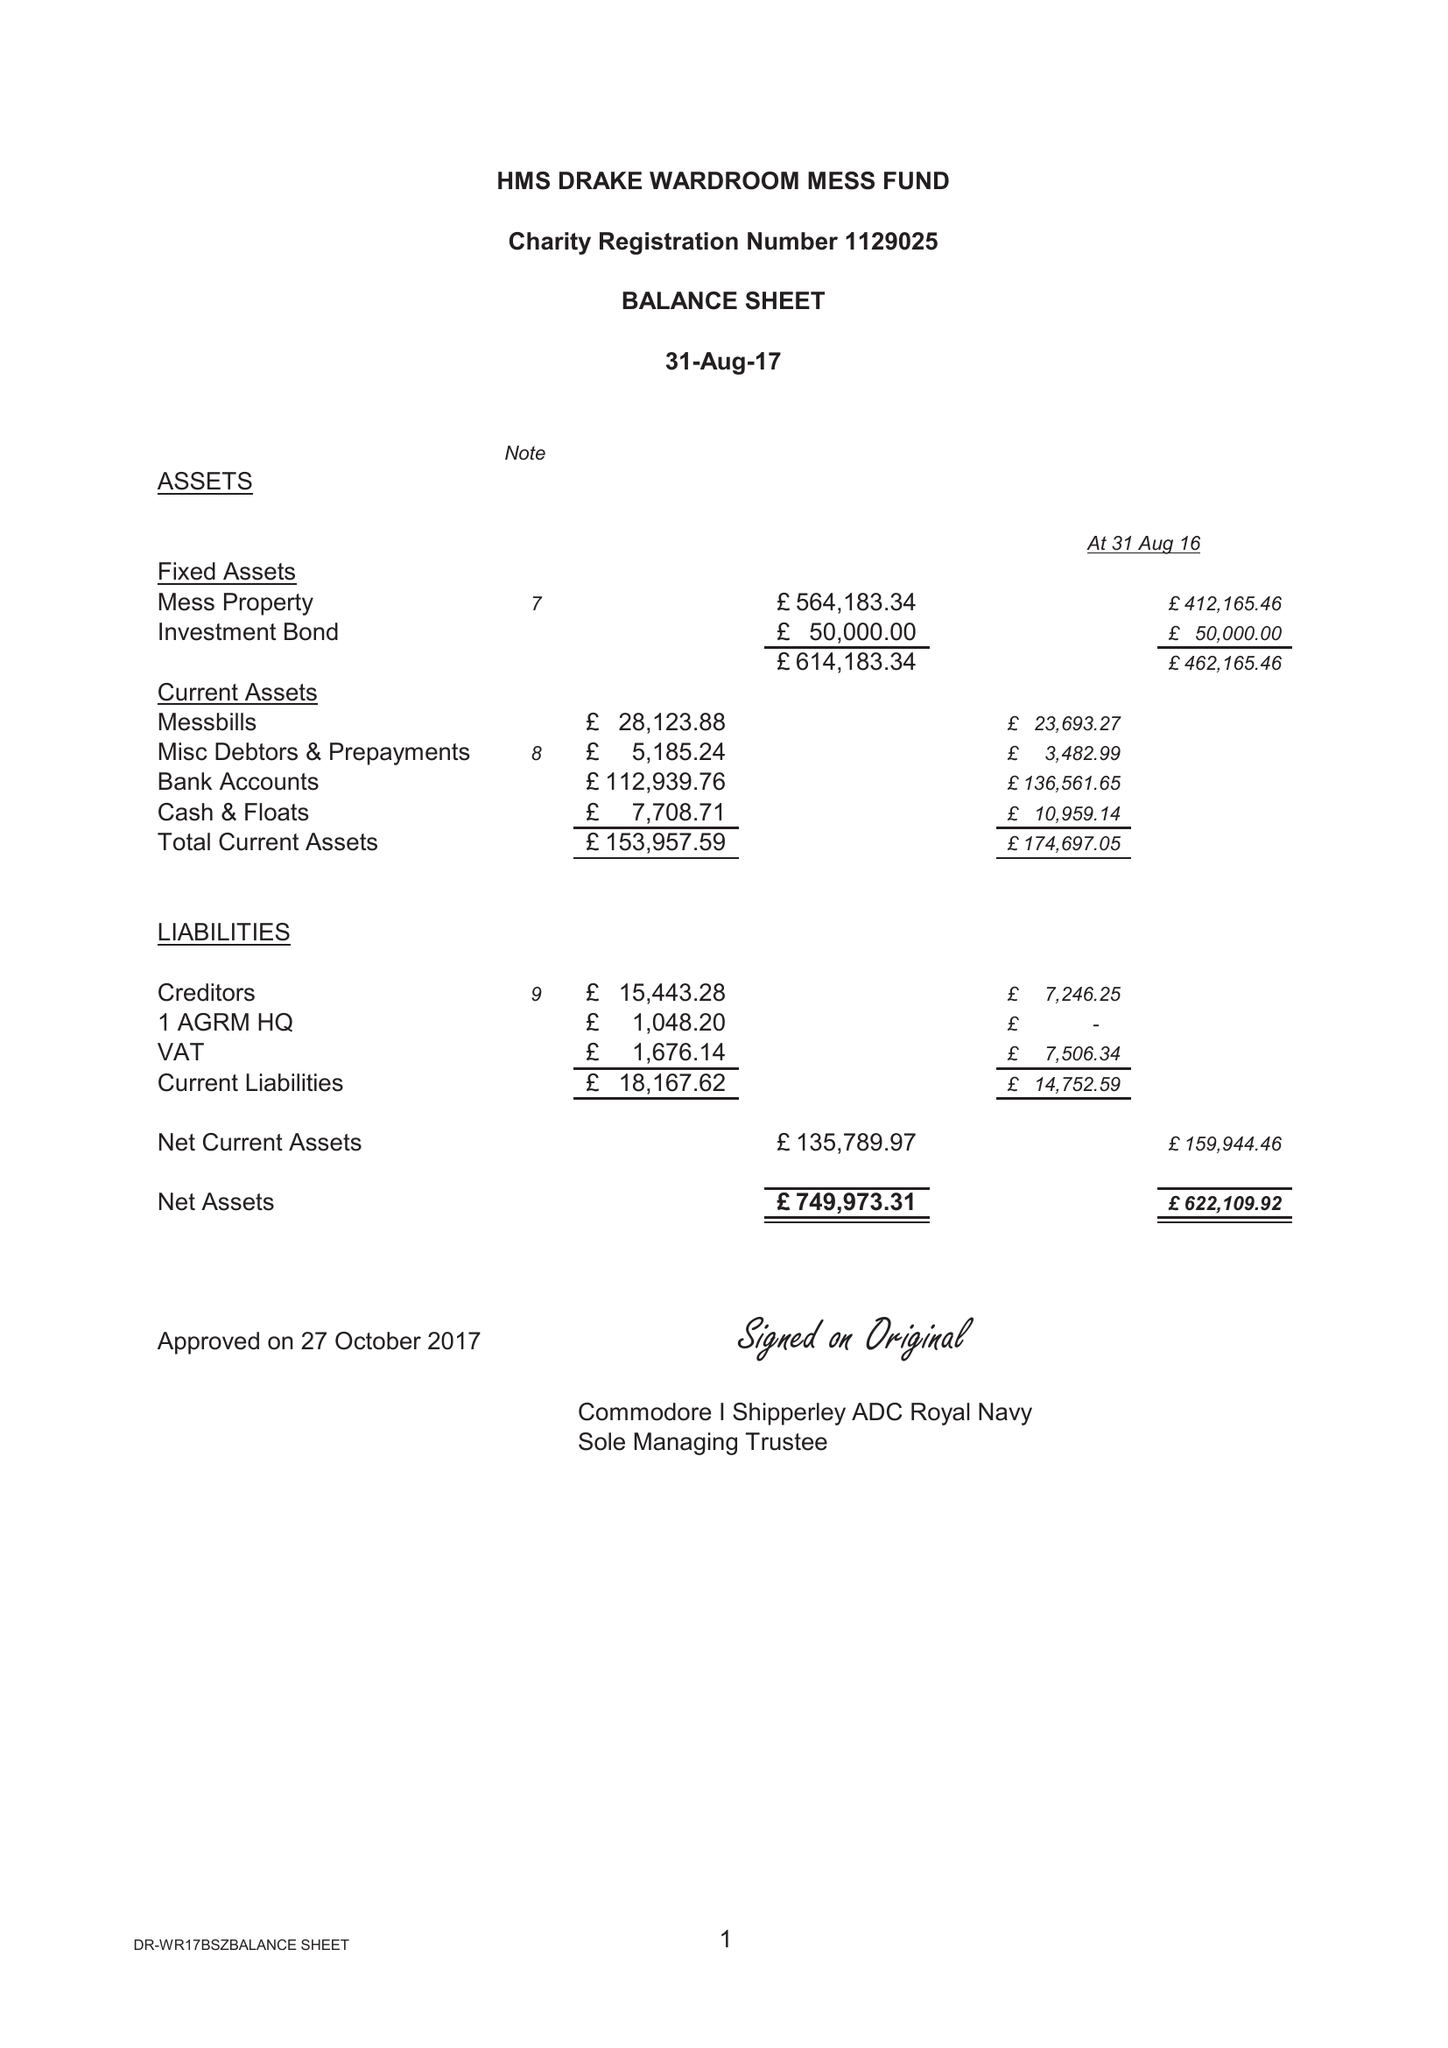What is the value for the spending_annually_in_british_pounds?
Answer the question using a single word or phrase. 188601.14 